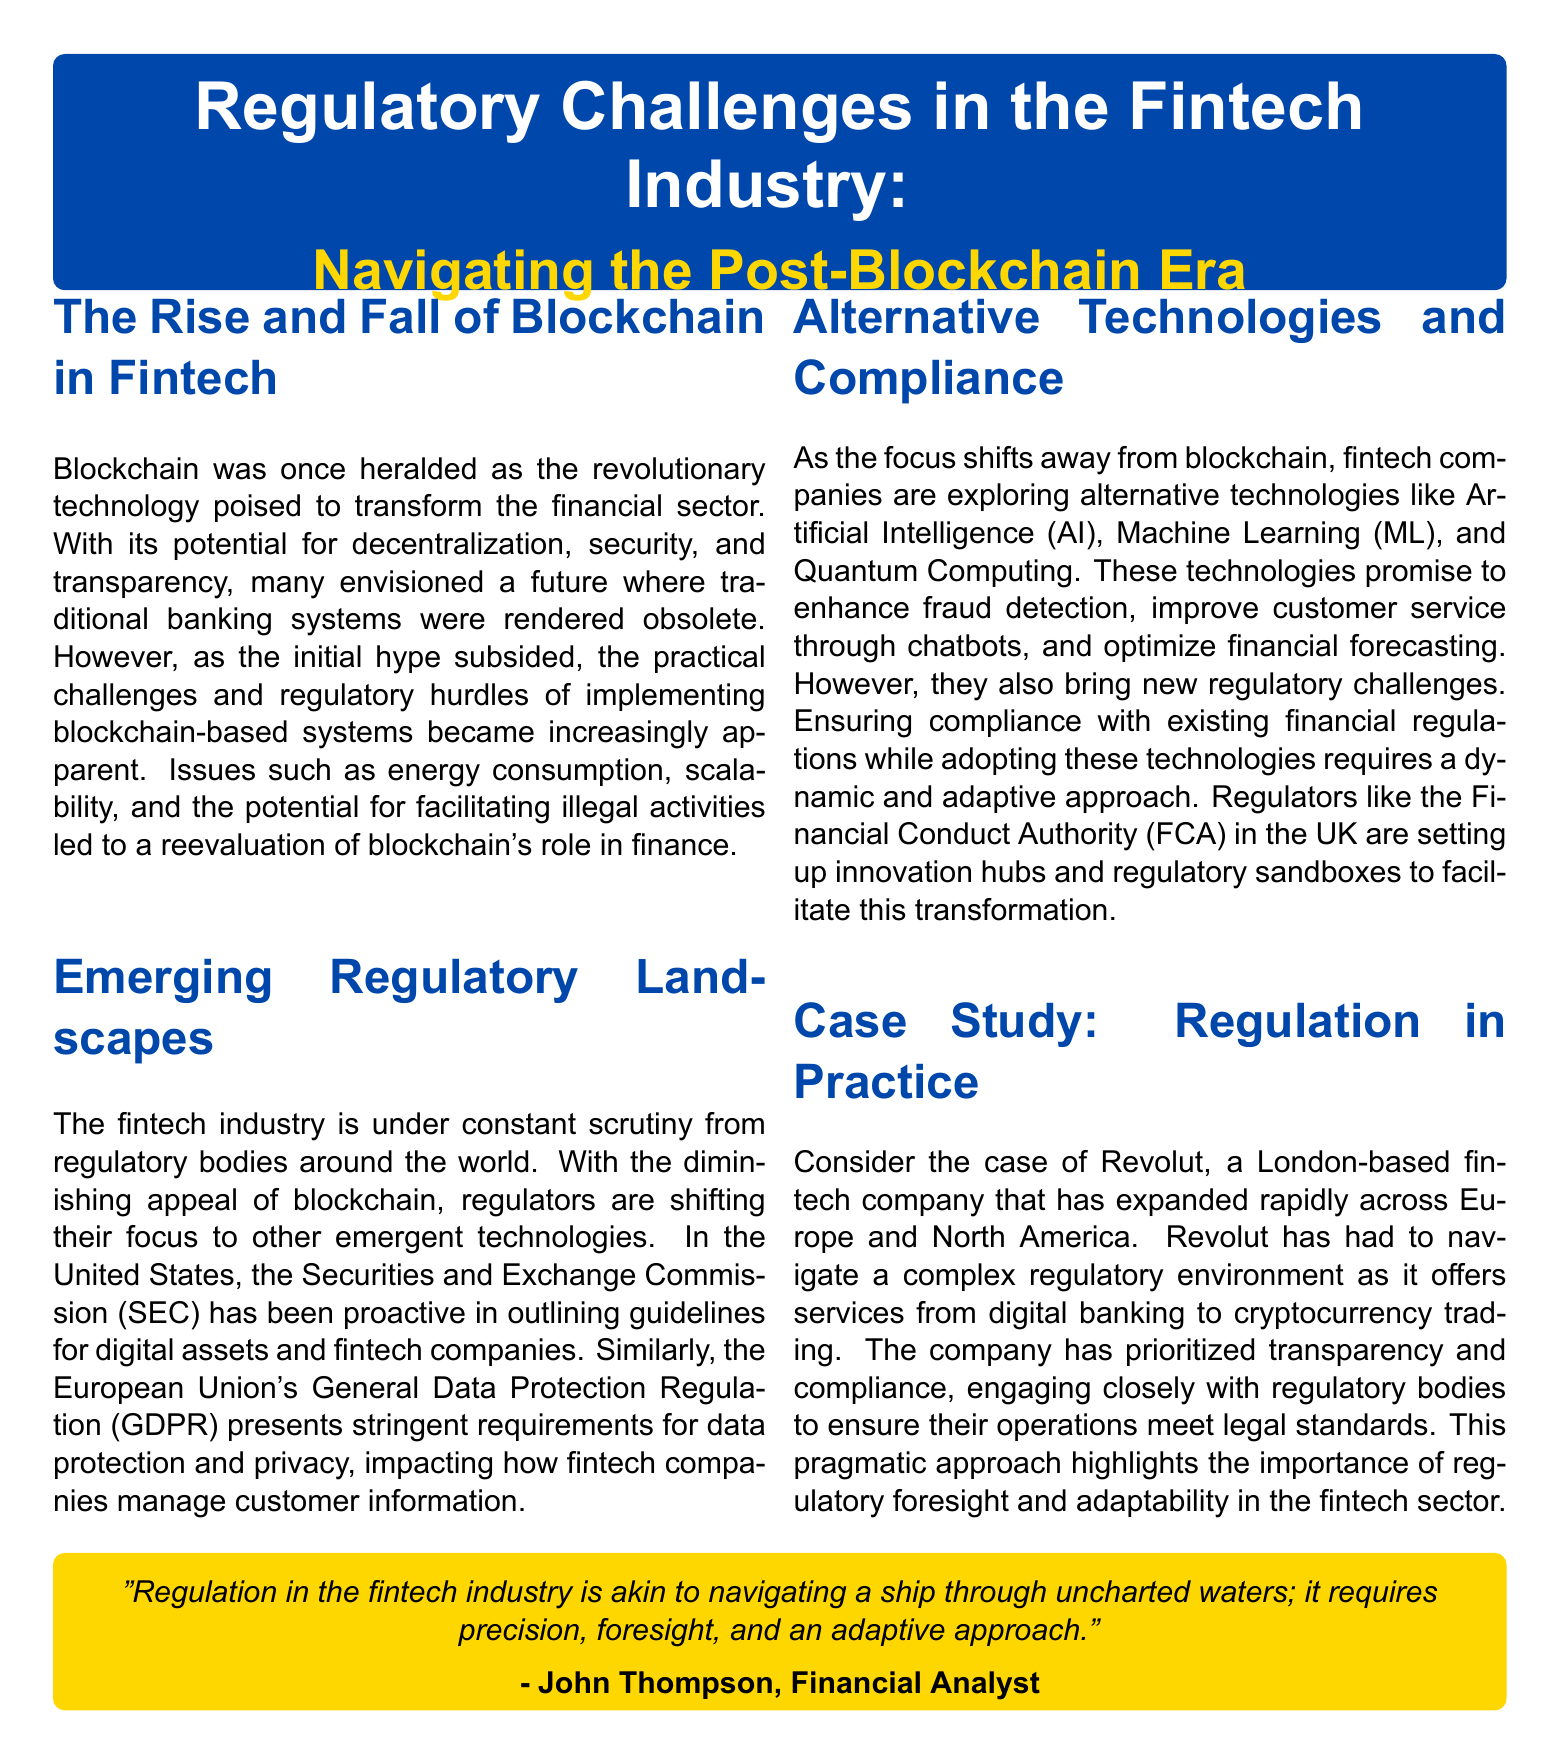What is the main color used in the document? The main color is indicated in the document as the primary theme color for various sections.
Answer: Blue Who is quoted in the document? The document contains a quote from John Thompson, who is identified as a financial analyst.
Answer: John Thompson What regulatory act is mentioned regarding data protection in the EU? The document refers to the General Data Protection Regulation that impacts fintech companies.
Answer: GDPR Which financial authority is highlighted for setting up innovation hubs? The Financial Conduct Authority is mentioned as the regulatory body facilitating innovation in the fintech sector.
Answer: FCA What company serves as a case study in the document? The document discusses Revolut as a prominent fintech company navigating regulatory challenges.
Answer: Revolut What technology is mentioned as a focus for fintech companies after blockchain? The document highlights alternative technologies being explored by fintech companies after the blockchain hype.
Answer: Artificial Intelligence What describes the regulatory landscape for fintech according to the document? The document indicates that the regulatory landscape is characterized by constant scrutiny from regulatory bodies worldwide.
Answer: Constant scrutiny What type of approach is necessary for fintech regulation according to the quote? The quote emphasizes that regulation in fintech requires precision, foresight, and an adaptive approach.
Answer: Adaptive approach What is the document type presented here? The structure and layout of the document suggest it is a magazine format focused on fintech regulation.
Answer: Magazine 